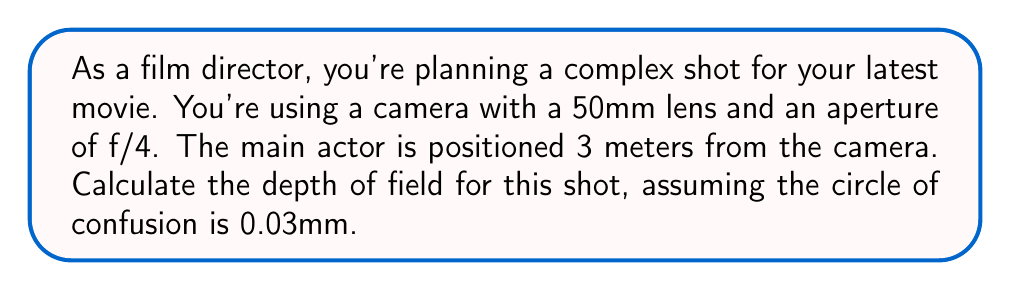Can you answer this question? To calculate the depth of field, we need to determine the near limit and far limit of acceptable sharpness. We'll use the following formulas:

1. Near limit: $$D_n = \frac{Hf^2}{f^2 + Nc(H-f)}$$
2. Far limit: $$D_f = \frac{Hf^2}{f^2 - Nc(H-f)}$$
3. Depth of Field: $$DoF = D_f - D_n$$

Where:
- $H$ is the subject distance (3m)
- $f$ is the focal length (50mm = 0.05m)
- $N$ is the f-number (4)
- $c$ is the circle of confusion (0.03mm = 0.00003m)

Step 1: Calculate the near limit
$$D_n = \frac{3 \cdot 0.05^2}{0.05^2 + 4 \cdot 0.00003(3-0.05)} = 2.82m$$

Step 2: Calculate the far limit
$$D_f = \frac{3 \cdot 0.05^2}{0.05^2 - 4 \cdot 0.00003(3-0.05)} = 3.20m$$

Step 3: Calculate the Depth of Field
$$DoF = D_f - D_n = 3.20m - 2.82m = 0.38m$$
Answer: The depth of field for this shot is approximately 0.38 meters (38 cm). 